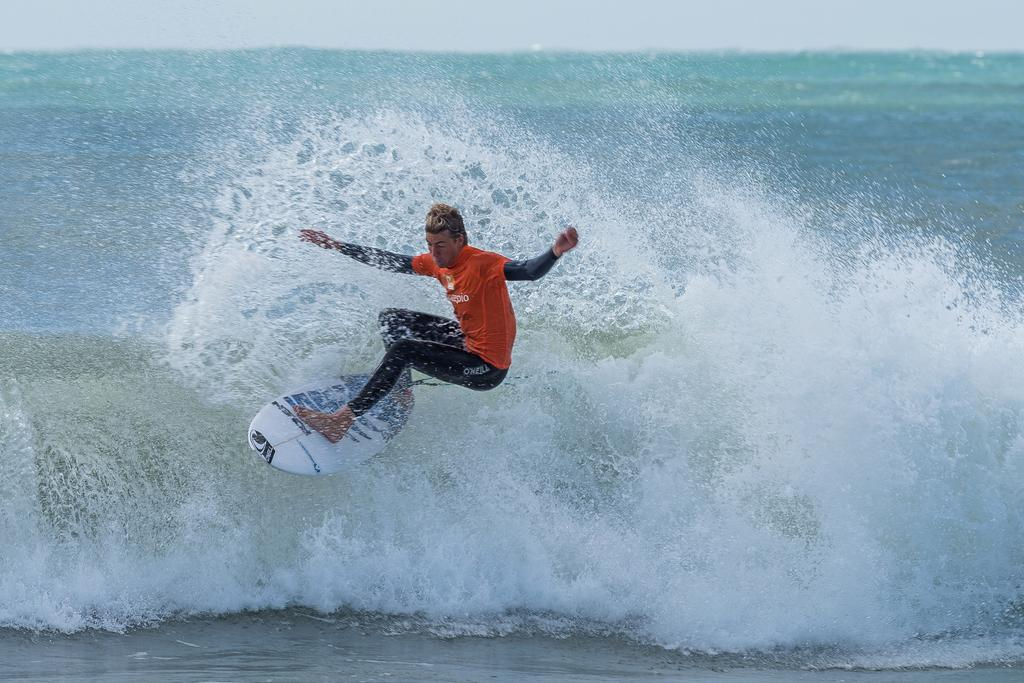<image>
Share a concise interpretation of the image provided. a surfer riding a wave in a orange shirt and black O'Neill pants 